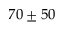<formula> <loc_0><loc_0><loc_500><loc_500>7 0 \pm 5 0</formula> 